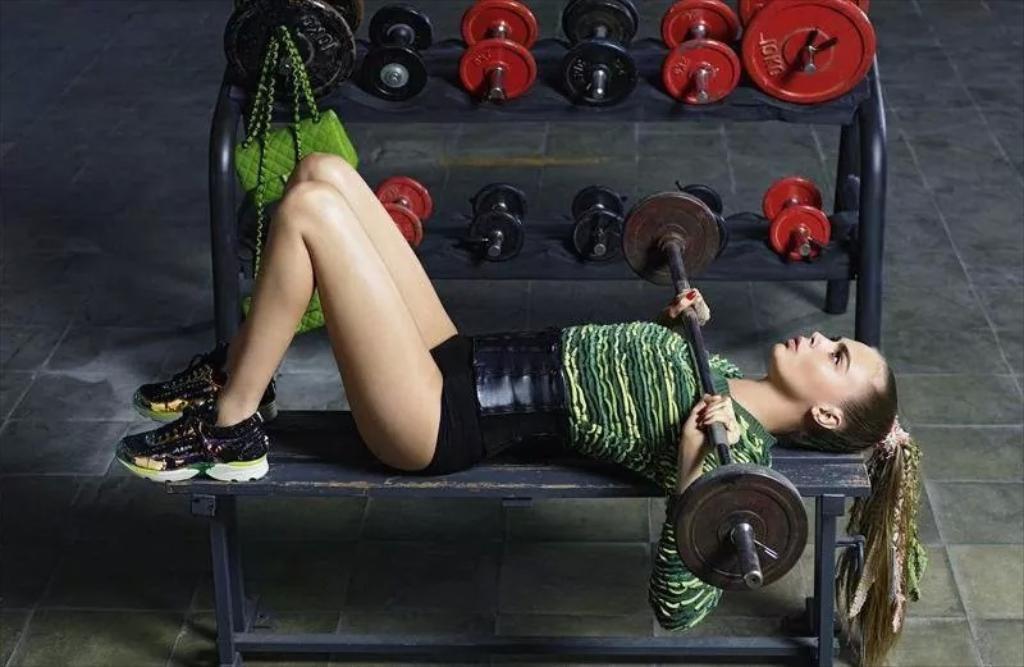Could you give a brief overview of what you see in this image? In this image there I can see a lady lying on the bench holding a weight lifting rod, beside her there are some dumbbells on the stand, also there are handbags. 